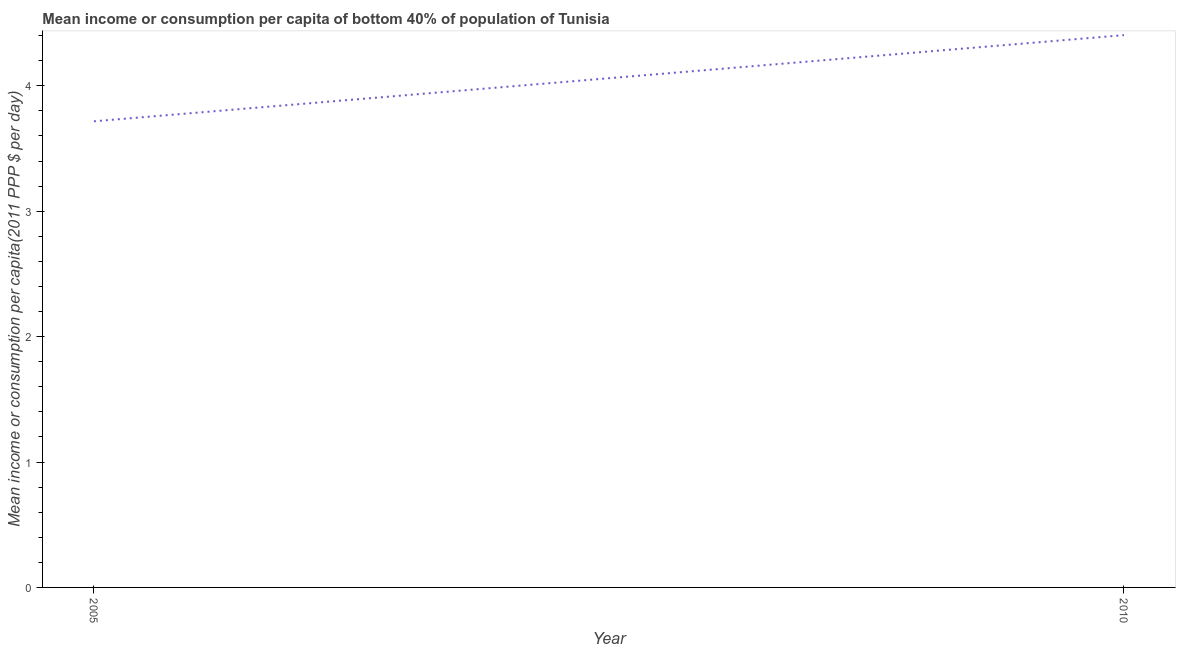What is the mean income or consumption in 2010?
Provide a short and direct response. 4.4. Across all years, what is the maximum mean income or consumption?
Offer a very short reply. 4.4. Across all years, what is the minimum mean income or consumption?
Offer a terse response. 3.72. In which year was the mean income or consumption maximum?
Provide a short and direct response. 2010. In which year was the mean income or consumption minimum?
Give a very brief answer. 2005. What is the sum of the mean income or consumption?
Your answer should be very brief. 8.12. What is the difference between the mean income or consumption in 2005 and 2010?
Your response must be concise. -0.69. What is the average mean income or consumption per year?
Offer a terse response. 4.06. What is the median mean income or consumption?
Offer a very short reply. 4.06. What is the ratio of the mean income or consumption in 2005 to that in 2010?
Provide a succinct answer. 0.84. Is the mean income or consumption in 2005 less than that in 2010?
Offer a very short reply. Yes. In how many years, is the mean income or consumption greater than the average mean income or consumption taken over all years?
Your answer should be very brief. 1. How many lines are there?
Keep it short and to the point. 1. Does the graph contain any zero values?
Your answer should be compact. No. What is the title of the graph?
Offer a terse response. Mean income or consumption per capita of bottom 40% of population of Tunisia. What is the label or title of the Y-axis?
Keep it short and to the point. Mean income or consumption per capita(2011 PPP $ per day). What is the Mean income or consumption per capita(2011 PPP $ per day) in 2005?
Offer a terse response. 3.72. What is the Mean income or consumption per capita(2011 PPP $ per day) of 2010?
Offer a terse response. 4.4. What is the difference between the Mean income or consumption per capita(2011 PPP $ per day) in 2005 and 2010?
Ensure brevity in your answer.  -0.69. What is the ratio of the Mean income or consumption per capita(2011 PPP $ per day) in 2005 to that in 2010?
Provide a succinct answer. 0.84. 